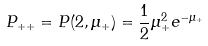Convert formula to latex. <formula><loc_0><loc_0><loc_500><loc_500>P _ { + + } = P ( 2 , \mu _ { + } ) = \frac { 1 } { 2 } \mu _ { + } ^ { 2 } e ^ { - \mu _ { + } }</formula> 